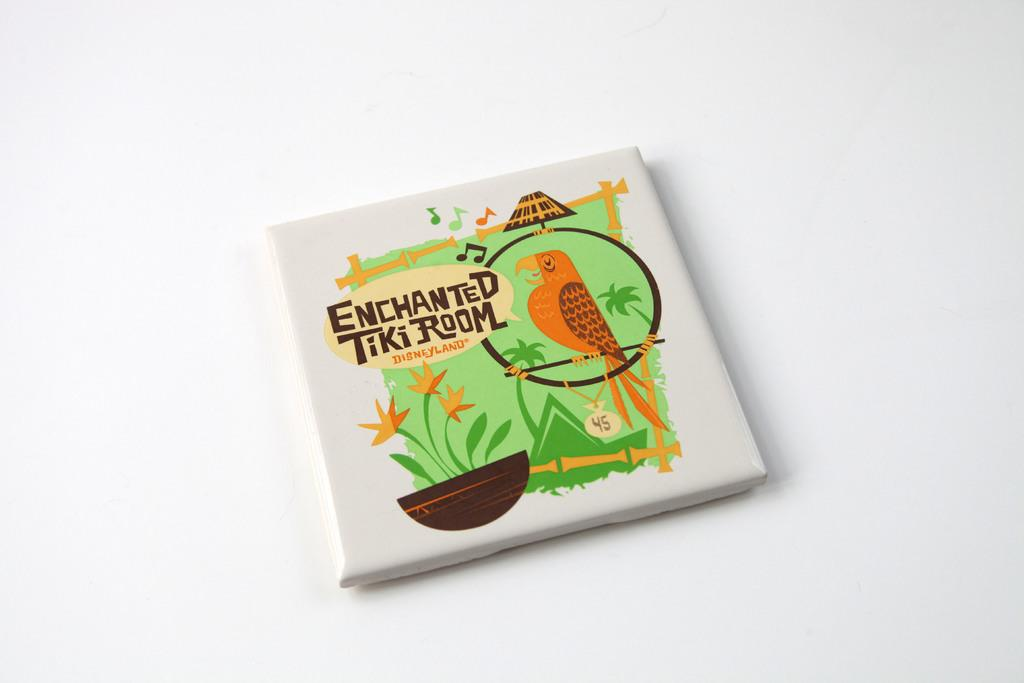What is the main subject of the image? The main subject of the image is a book. What is the title of the book? The book is named "An Enchanted Tiki Room." What is placed on top of the book? There is a pot with flowers on the book. What type of illustration can be seen on the book? There is a bird depicted on the book. What type of amusement can be seen in the hole on the book? There is no hole or amusement present on the book; it features a pot with flowers and a bird illustration. 